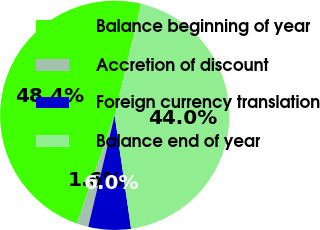Convert chart to OTSL. <chart><loc_0><loc_0><loc_500><loc_500><pie_chart><fcel>Balance beginning of year<fcel>Accretion of discount<fcel>Foreign currency translation<fcel>Balance end of year<nl><fcel>48.36%<fcel>1.64%<fcel>5.99%<fcel>44.01%<nl></chart> 